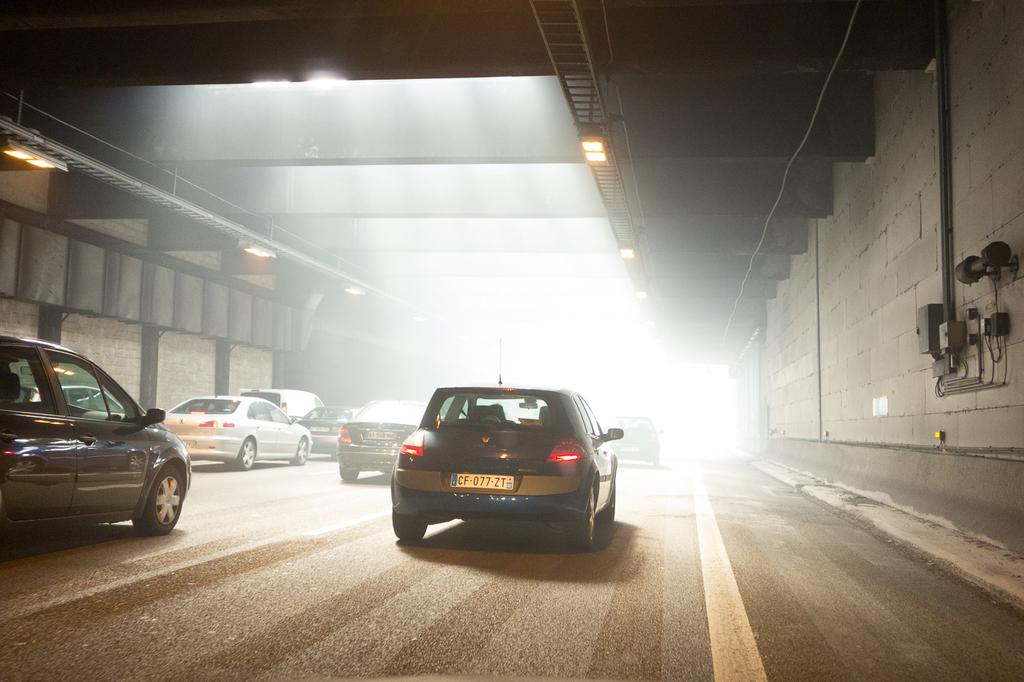What is the main subject of the image? The main subject of the image appears to be a tunnel. What can be seen in the middle of the tunnel? There are cars in the middle of the image. What colors are some of the cars in the image? Some of the cars are black, and some are white. What is providing illumination in the tunnel? There are lights in the middle of the tunnel. Can you tell me how many lawyers are present in the image? There are no lawyers present in the image; it features a tunnel with cars and lights. What type of change can be seen happening to the tunnel in the image? There is no change happening to the tunnel in the image; it is a static representation. 